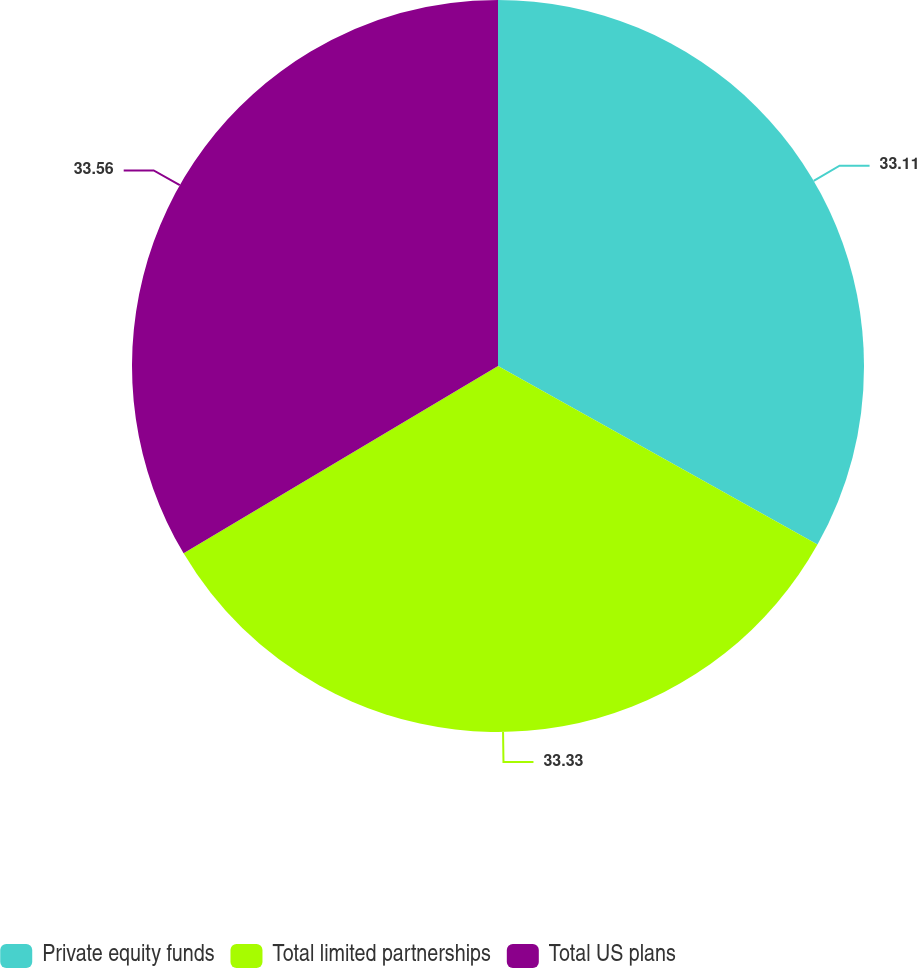Convert chart to OTSL. <chart><loc_0><loc_0><loc_500><loc_500><pie_chart><fcel>Private equity funds<fcel>Total limited partnerships<fcel>Total US plans<nl><fcel>33.11%<fcel>33.33%<fcel>33.55%<nl></chart> 